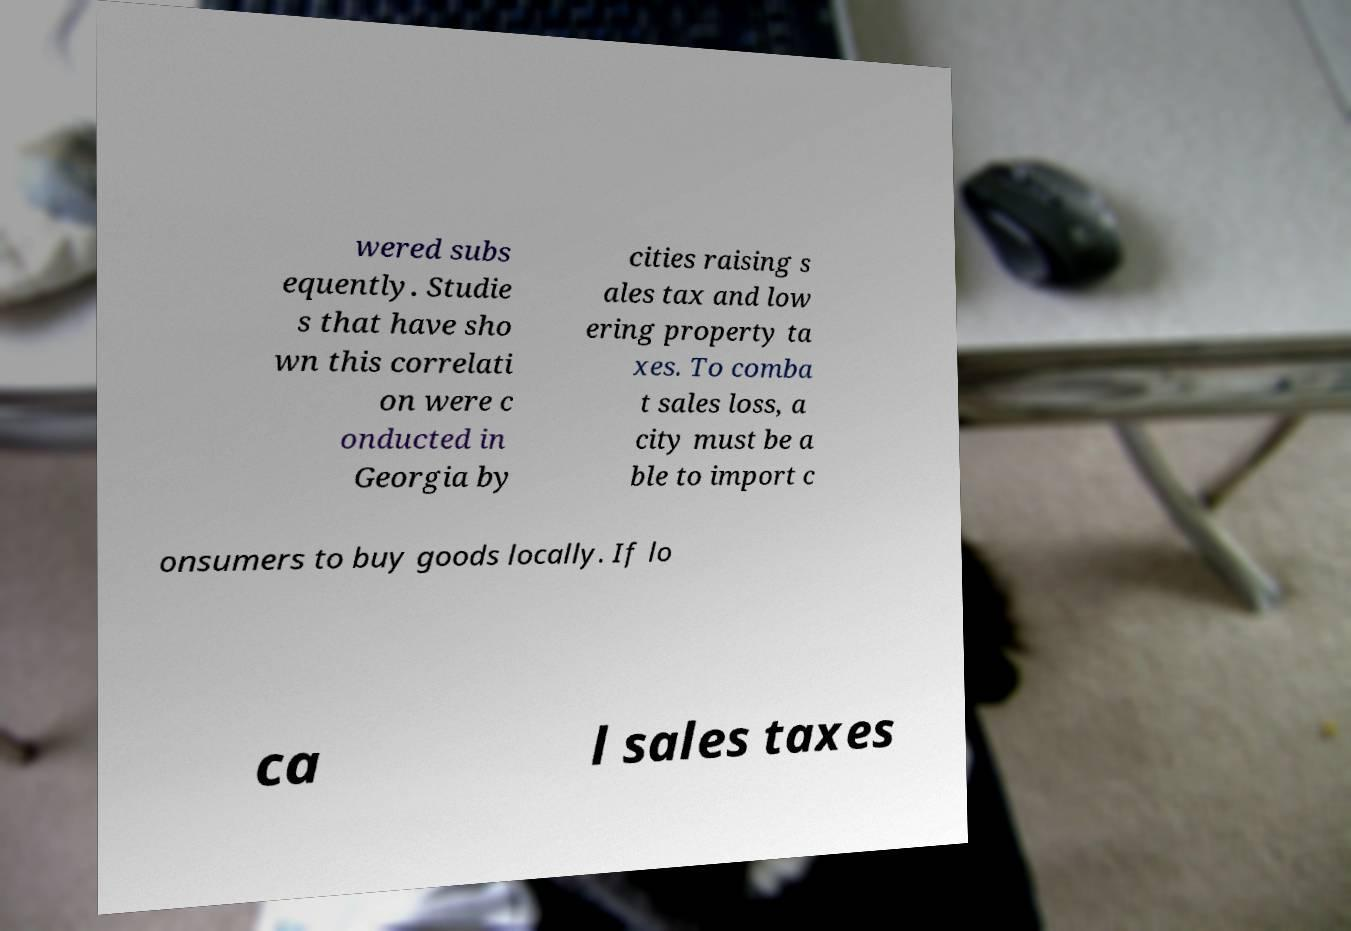Could you assist in decoding the text presented in this image and type it out clearly? wered subs equently. Studie s that have sho wn this correlati on were c onducted in Georgia by cities raising s ales tax and low ering property ta xes. To comba t sales loss, a city must be a ble to import c onsumers to buy goods locally. If lo ca l sales taxes 